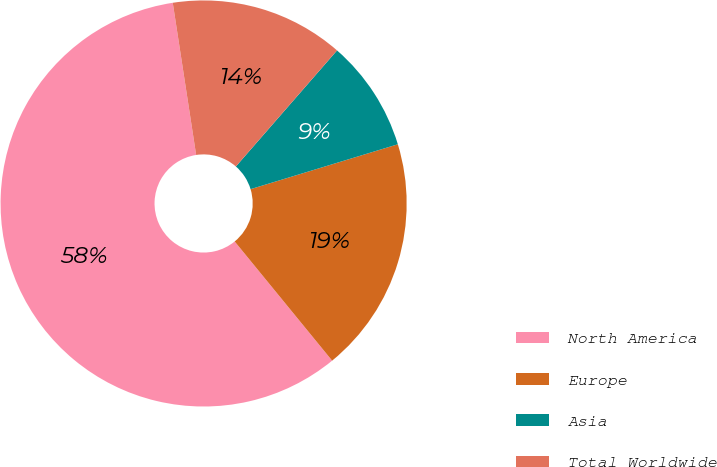<chart> <loc_0><loc_0><loc_500><loc_500><pie_chart><fcel>North America<fcel>Europe<fcel>Asia<fcel>Total Worldwide<nl><fcel>58.48%<fcel>18.8%<fcel>8.88%<fcel>13.84%<nl></chart> 